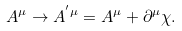<formula> <loc_0><loc_0><loc_500><loc_500>A ^ { \mu } \rightarrow A ^ { ^ { \prime } \mu } = A ^ { \mu } + \partial ^ { \mu } \chi .</formula> 